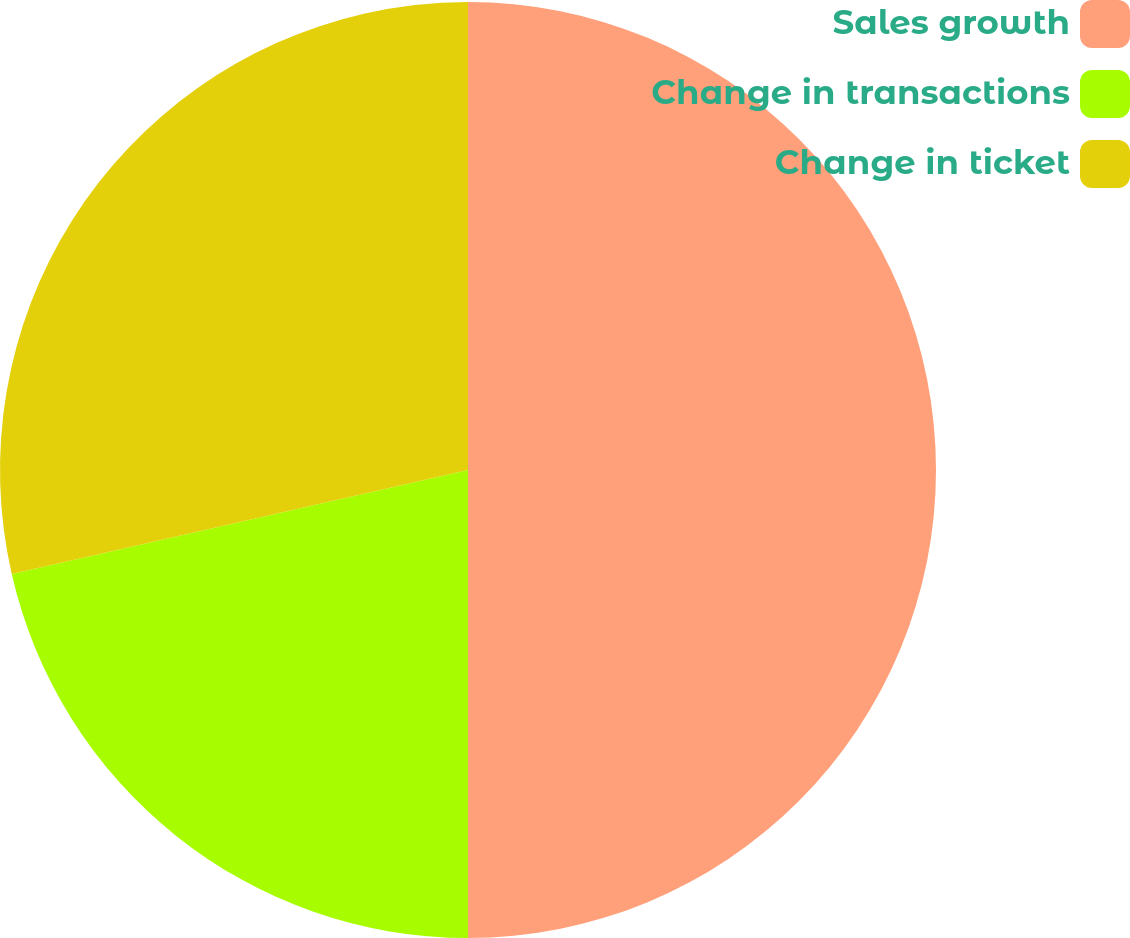<chart> <loc_0><loc_0><loc_500><loc_500><pie_chart><fcel>Sales growth<fcel>Change in transactions<fcel>Change in ticket<nl><fcel>50.0%<fcel>21.43%<fcel>28.57%<nl></chart> 